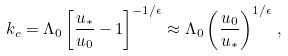<formula> <loc_0><loc_0><loc_500><loc_500>k _ { c } = \Lambda _ { 0 } \left [ \frac { u _ { \ast } } { u _ { 0 } } - 1 \right ] ^ { - 1 / \epsilon } \approx \Lambda _ { 0 } \left ( \frac { u _ { 0 } } { u _ { \ast } } \right ) ^ { 1 / \epsilon } \, ,</formula> 